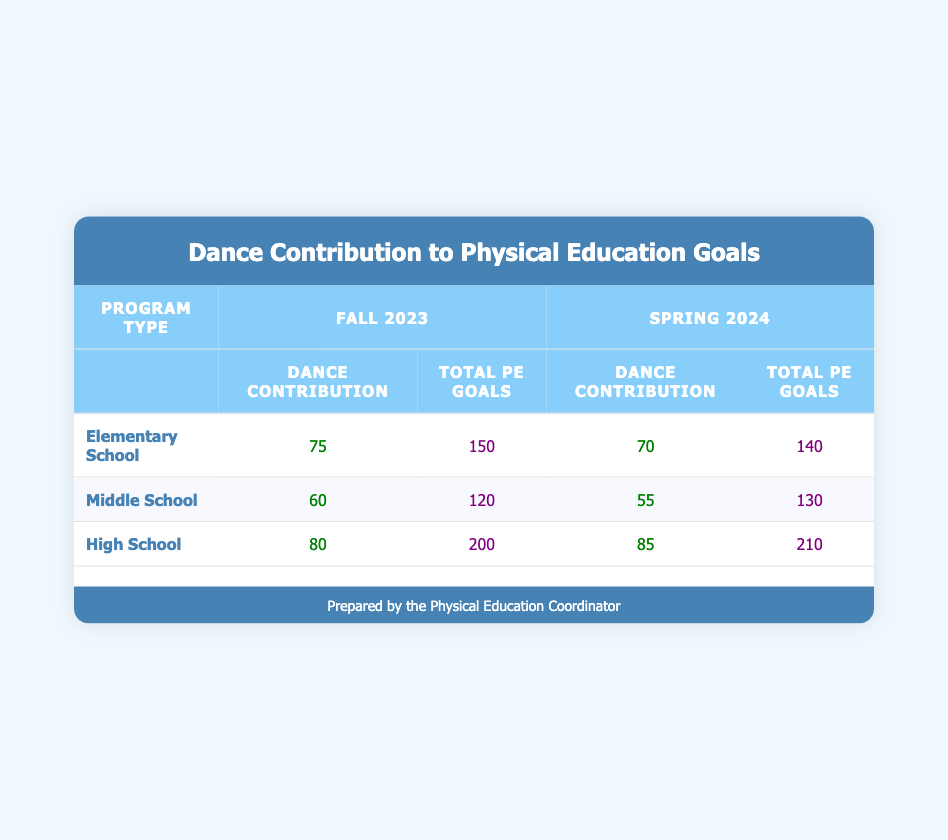What is the dance activity contribution for High School students in Fall 2023? The table entry for High School students in Fall 2023 shows a dance activity contribution of 80.
Answer: 80 What is the total physical education goal for Middle School in Spring 2024? From the table, the total physical education goal for Middle School in Spring 2024 is stated as 130.
Answer: 130 Which program type had the highest dance activity contribution in Fall 2023? By comparing the dance contributions in Fall 2023, Elementary School has 75, Middle School has 60, and High School has 80. High School has the highest contribution among them.
Answer: High School What is the average dance activity contribution across all program types for Fall 2023? The contributions in Fall 2023 are 75, 60, and 80. Adding them gives 75 + 60 + 80 = 215. There are 3 program types, so the average is 215 divided by 3, which is approximately 71.67.
Answer: 71.67 Did Middle School have a higher dance contribution in Fall 2023 compared to Spring 2024? In Fall 2023, Middle School's dance contribution was 60, and in Spring 2024, it was 55. Since 60 is greater than 55, the answer is yes.
Answer: Yes What is the difference in total physical education goals for Elementary School between Fall 2023 and Spring 2024? The total physical education goals for Elementary School in Fall 2023 is 150, and in Spring 2024 is 140. The difference is 150 - 140 = 10.
Answer: 10 Which program type improved its dance activity contribution from Fall 2023 to Spring 2024? Looking at the table, High School increased from 80 in Fall 2023 to 85 in Spring 2024. This indicates an improvement.
Answer: High School Was the dance activity contribution higher in Spring 2024 for any program type compared to its Fall 2023 contribution? In Spring 2024, High School had a contribution of 85, which is higher than its Fall 2023 contribution of 80. Other program types did not show an increase, confirming that High School is the only type with a higher contribution in Spring 2024.
Answer: Yes What is the total dance activity contribution for all program types in Spring 2024? The dance contributions for Spring 2024 are 70 (Elementary), 55 (Middle), and 85 (High). Adding these gives 70 + 55 + 85 = 210.
Answer: 210 